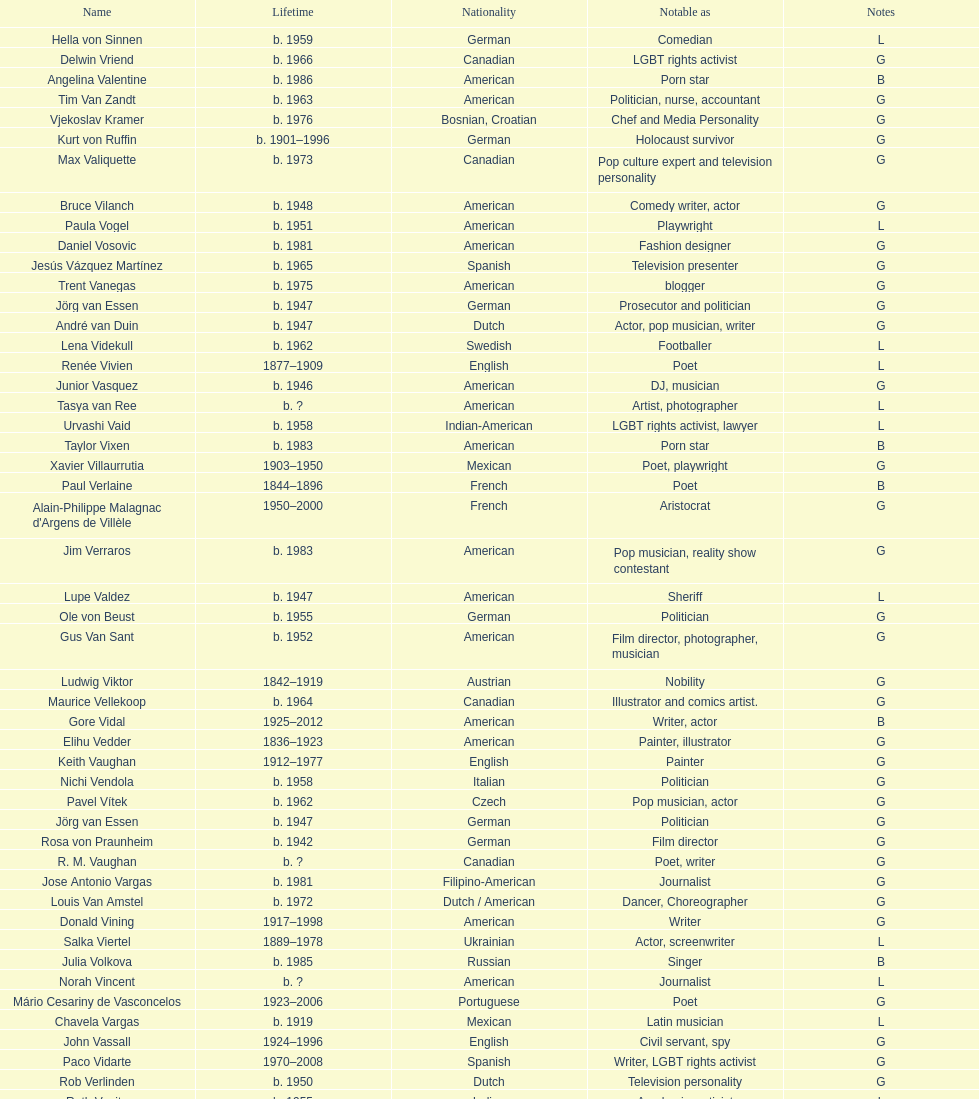Patricia velasquez and ron vawter both pursued which profession? Actor. 